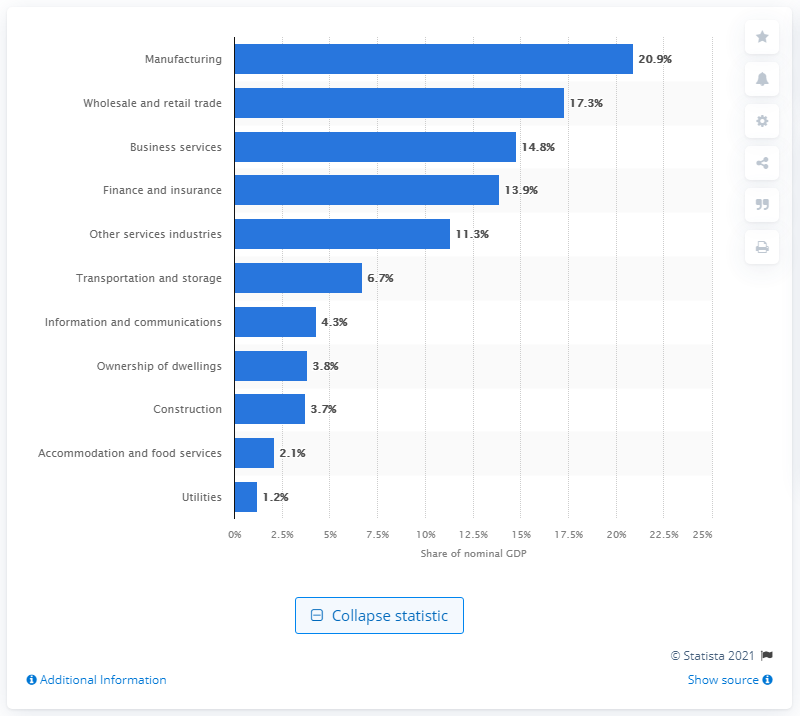Indicate a few pertinent items in this graphic. In 2019, the manufacturing sector contributed 20.9% to Singapore's Gross Domestic Product (GDP). 